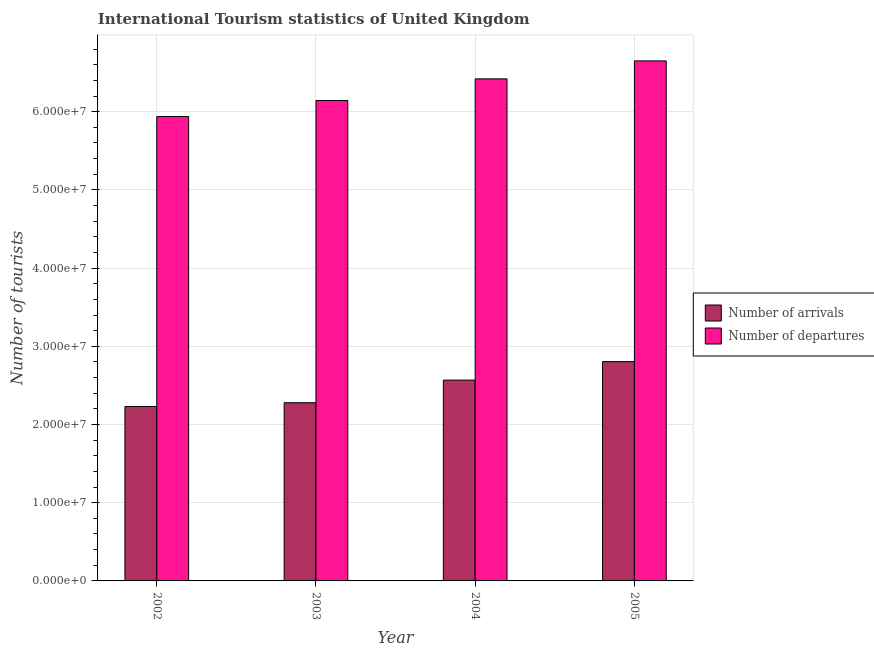How many different coloured bars are there?
Make the answer very short. 2. Are the number of bars per tick equal to the number of legend labels?
Your answer should be compact. Yes. Are the number of bars on each tick of the X-axis equal?
Provide a succinct answer. Yes. How many bars are there on the 1st tick from the right?
Make the answer very short. 2. What is the number of tourist departures in 2004?
Offer a terse response. 6.42e+07. Across all years, what is the maximum number of tourist arrivals?
Provide a short and direct response. 2.80e+07. Across all years, what is the minimum number of tourist arrivals?
Offer a terse response. 2.23e+07. In which year was the number of tourist departures minimum?
Your response must be concise. 2002. What is the total number of tourist arrivals in the graph?
Offer a terse response. 9.88e+07. What is the difference between the number of tourist arrivals in 2003 and that in 2005?
Give a very brief answer. -5.25e+06. What is the difference between the number of tourist departures in 2004 and the number of tourist arrivals in 2002?
Offer a very short reply. 4.82e+06. What is the average number of tourist departures per year?
Make the answer very short. 6.29e+07. In how many years, is the number of tourist arrivals greater than 26000000?
Offer a very short reply. 1. What is the ratio of the number of tourist arrivals in 2002 to that in 2004?
Keep it short and to the point. 0.87. What is the difference between the highest and the second highest number of tourist arrivals?
Keep it short and to the point. 2.36e+06. What is the difference between the highest and the lowest number of tourist arrivals?
Your response must be concise. 5.73e+06. In how many years, is the number of tourist departures greater than the average number of tourist departures taken over all years?
Offer a terse response. 2. Is the sum of the number of tourist arrivals in 2003 and 2004 greater than the maximum number of tourist departures across all years?
Your response must be concise. Yes. What does the 2nd bar from the left in 2005 represents?
Your answer should be very brief. Number of departures. What does the 2nd bar from the right in 2005 represents?
Ensure brevity in your answer.  Number of arrivals. How many bars are there?
Your response must be concise. 8. Are all the bars in the graph horizontal?
Offer a terse response. No. Does the graph contain any zero values?
Offer a terse response. No. Where does the legend appear in the graph?
Offer a terse response. Center right. How many legend labels are there?
Keep it short and to the point. 2. How are the legend labels stacked?
Make the answer very short. Vertical. What is the title of the graph?
Your answer should be compact. International Tourism statistics of United Kingdom. Does "Tetanus" appear as one of the legend labels in the graph?
Offer a very short reply. No. What is the label or title of the X-axis?
Ensure brevity in your answer.  Year. What is the label or title of the Y-axis?
Provide a succinct answer. Number of tourists. What is the Number of tourists of Number of arrivals in 2002?
Provide a short and direct response. 2.23e+07. What is the Number of tourists of Number of departures in 2002?
Your answer should be very brief. 5.94e+07. What is the Number of tourists in Number of arrivals in 2003?
Make the answer very short. 2.28e+07. What is the Number of tourists in Number of departures in 2003?
Your answer should be compact. 6.14e+07. What is the Number of tourists in Number of arrivals in 2004?
Give a very brief answer. 2.57e+07. What is the Number of tourists of Number of departures in 2004?
Your response must be concise. 6.42e+07. What is the Number of tourists of Number of arrivals in 2005?
Offer a very short reply. 2.80e+07. What is the Number of tourists in Number of departures in 2005?
Provide a succinct answer. 6.65e+07. Across all years, what is the maximum Number of tourists in Number of arrivals?
Your answer should be very brief. 2.80e+07. Across all years, what is the maximum Number of tourists of Number of departures?
Make the answer very short. 6.65e+07. Across all years, what is the minimum Number of tourists in Number of arrivals?
Ensure brevity in your answer.  2.23e+07. Across all years, what is the minimum Number of tourists in Number of departures?
Offer a very short reply. 5.94e+07. What is the total Number of tourists in Number of arrivals in the graph?
Offer a very short reply. 9.88e+07. What is the total Number of tourists in Number of departures in the graph?
Provide a succinct answer. 2.51e+08. What is the difference between the Number of tourists of Number of arrivals in 2002 and that in 2003?
Provide a short and direct response. -4.80e+05. What is the difference between the Number of tourists of Number of departures in 2002 and that in 2003?
Ensure brevity in your answer.  -2.05e+06. What is the difference between the Number of tourists in Number of arrivals in 2002 and that in 2004?
Your answer should be very brief. -3.37e+06. What is the difference between the Number of tourists in Number of departures in 2002 and that in 2004?
Your answer should be very brief. -4.82e+06. What is the difference between the Number of tourists of Number of arrivals in 2002 and that in 2005?
Give a very brief answer. -5.73e+06. What is the difference between the Number of tourists in Number of departures in 2002 and that in 2005?
Offer a very short reply. -7.12e+06. What is the difference between the Number of tourists in Number of arrivals in 2003 and that in 2004?
Provide a short and direct response. -2.89e+06. What is the difference between the Number of tourists in Number of departures in 2003 and that in 2004?
Your response must be concise. -2.77e+06. What is the difference between the Number of tourists in Number of arrivals in 2003 and that in 2005?
Your answer should be very brief. -5.25e+06. What is the difference between the Number of tourists in Number of departures in 2003 and that in 2005?
Give a very brief answer. -5.07e+06. What is the difference between the Number of tourists of Number of arrivals in 2004 and that in 2005?
Your response must be concise. -2.36e+06. What is the difference between the Number of tourists of Number of departures in 2004 and that in 2005?
Offer a terse response. -2.30e+06. What is the difference between the Number of tourists in Number of arrivals in 2002 and the Number of tourists in Number of departures in 2003?
Provide a succinct answer. -3.91e+07. What is the difference between the Number of tourists of Number of arrivals in 2002 and the Number of tourists of Number of departures in 2004?
Provide a succinct answer. -4.19e+07. What is the difference between the Number of tourists of Number of arrivals in 2002 and the Number of tourists of Number of departures in 2005?
Your response must be concise. -4.42e+07. What is the difference between the Number of tourists in Number of arrivals in 2003 and the Number of tourists in Number of departures in 2004?
Your answer should be very brief. -4.14e+07. What is the difference between the Number of tourists of Number of arrivals in 2003 and the Number of tourists of Number of departures in 2005?
Offer a terse response. -4.37e+07. What is the difference between the Number of tourists in Number of arrivals in 2004 and the Number of tourists in Number of departures in 2005?
Provide a succinct answer. -4.08e+07. What is the average Number of tourists of Number of arrivals per year?
Offer a very short reply. 2.47e+07. What is the average Number of tourists in Number of departures per year?
Offer a very short reply. 6.29e+07. In the year 2002, what is the difference between the Number of tourists in Number of arrivals and Number of tourists in Number of departures?
Your answer should be compact. -3.71e+07. In the year 2003, what is the difference between the Number of tourists in Number of arrivals and Number of tourists in Number of departures?
Keep it short and to the point. -3.86e+07. In the year 2004, what is the difference between the Number of tourists of Number of arrivals and Number of tourists of Number of departures?
Make the answer very short. -3.85e+07. In the year 2005, what is the difference between the Number of tourists in Number of arrivals and Number of tourists in Number of departures?
Your answer should be very brief. -3.85e+07. What is the ratio of the Number of tourists of Number of arrivals in 2002 to that in 2003?
Offer a very short reply. 0.98. What is the ratio of the Number of tourists in Number of departures in 2002 to that in 2003?
Offer a very short reply. 0.97. What is the ratio of the Number of tourists of Number of arrivals in 2002 to that in 2004?
Give a very brief answer. 0.87. What is the ratio of the Number of tourists of Number of departures in 2002 to that in 2004?
Your answer should be very brief. 0.93. What is the ratio of the Number of tourists of Number of arrivals in 2002 to that in 2005?
Offer a very short reply. 0.8. What is the ratio of the Number of tourists in Number of departures in 2002 to that in 2005?
Your response must be concise. 0.89. What is the ratio of the Number of tourists in Number of arrivals in 2003 to that in 2004?
Your response must be concise. 0.89. What is the ratio of the Number of tourists in Number of departures in 2003 to that in 2004?
Provide a succinct answer. 0.96. What is the ratio of the Number of tourists in Number of arrivals in 2003 to that in 2005?
Your answer should be compact. 0.81. What is the ratio of the Number of tourists in Number of departures in 2003 to that in 2005?
Give a very brief answer. 0.92. What is the ratio of the Number of tourists in Number of arrivals in 2004 to that in 2005?
Your response must be concise. 0.92. What is the ratio of the Number of tourists in Number of departures in 2004 to that in 2005?
Offer a terse response. 0.97. What is the difference between the highest and the second highest Number of tourists in Number of arrivals?
Keep it short and to the point. 2.36e+06. What is the difference between the highest and the second highest Number of tourists in Number of departures?
Keep it short and to the point. 2.30e+06. What is the difference between the highest and the lowest Number of tourists in Number of arrivals?
Keep it short and to the point. 5.73e+06. What is the difference between the highest and the lowest Number of tourists in Number of departures?
Offer a very short reply. 7.12e+06. 